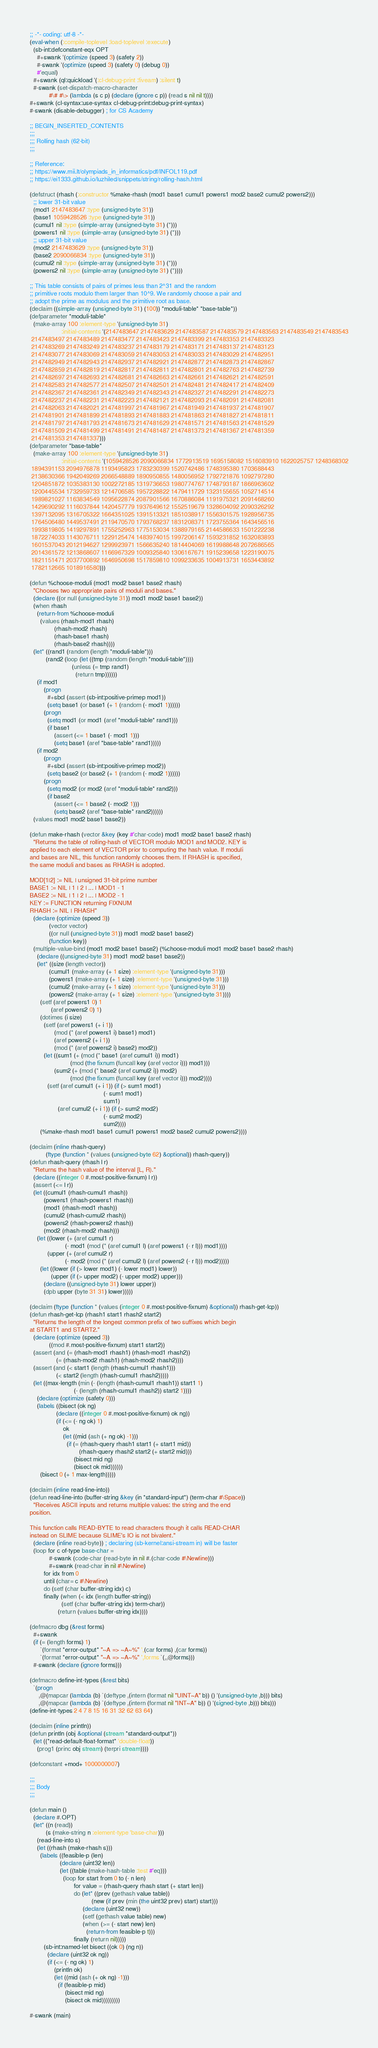Convert code to text. <code><loc_0><loc_0><loc_500><loc_500><_Lisp_>;; -*- coding: utf-8 -*-
(eval-when (:compile-toplevel :load-toplevel :execute)
  (sb-int:defconstant-eqx OPT
    #+swank '(optimize (speed 3) (safety 2))
    #-swank '(optimize (speed 3) (safety 0) (debug 0))
    #'equal)
  #+swank (ql:quickload '(:cl-debug-print :fiveam) :silent t)
  #-swank (set-dispatch-macro-character
           #\# #\> (lambda (s c p) (declare (ignore c p)) (read s nil nil t))))
#+swank (cl-syntax:use-syntax cl-debug-print:debug-print-syntax)
#-swank (disable-debugger) ; for CS Academy

;; BEGIN_INSERTED_CONTENTS
;;;
;;; Rolling hash (62-bit)
;;;

;; Reference:
;; https://www.mii.lt/olympiads_in_informatics/pdf/INFOL119.pdf
;; https://ei1333.github.io/luzhiled/snippets/string/rolling-hash.html

(defstruct (rhash (:constructor %make-rhash (mod1 base1 cumul1 powers1 mod2 base2 cumul2 powers2)))
  ;; lower 31-bit value
  (mod1 2147483647 :type (unsigned-byte 31))
  (base1 1059428526 :type (unsigned-byte 31))
  (cumul1 nil :type (simple-array (unsigned-byte 31) (*)))
  (powers1 nil :type (simple-array (unsigned-byte 31) (*)))
  ;; upper 31-bit value
  (mod2 2147483629 :type (unsigned-byte 31))
  (base2 2090066834 :type (unsigned-byte 31))
  (cumul2 nil :type (simple-array (unsigned-byte 31) (*)))
  (powers2 nil :type (simple-array (unsigned-byte 31) (*))))

;; This table consists of pairs of primes less than 2^31 and the random
;; primitive roots modulo them larger than 10^9. We randomly choose a pair and
;; adopt the prime as modulus and the primitive root as base.
(declaim ((simple-array (unsigned-byte 31) (100)) *moduli-table* *base-table*))
(defparameter *moduli-table*
  (make-array 100 :element-type '(unsigned-byte 31)
                  :initial-contents '(2147483647 2147483629 2147483587 2147483579 2147483563 2147483549 2147483543
 2147483497 2147483489 2147483477 2147483423 2147483399 2147483353 2147483323
 2147483269 2147483249 2147483237 2147483179 2147483171 2147483137 2147483123
 2147483077 2147483069 2147483059 2147483053 2147483033 2147483029 2147482951
 2147482949 2147482943 2147482937 2147482921 2147482877 2147482873 2147482867
 2147482859 2147482819 2147482817 2147482811 2147482801 2147482763 2147482739
 2147482697 2147482693 2147482681 2147482663 2147482661 2147482621 2147482591
 2147482583 2147482577 2147482507 2147482501 2147482481 2147482417 2147482409
 2147482367 2147482361 2147482349 2147482343 2147482327 2147482291 2147482273
 2147482237 2147482231 2147482223 2147482121 2147482093 2147482091 2147482081
 2147482063 2147482021 2147481997 2147481967 2147481949 2147481937 2147481907
 2147481901 2147481899 2147481893 2147481883 2147481863 2147481827 2147481811
 2147481797 2147481793 2147481673 2147481629 2147481571 2147481563 2147481529
 2147481509 2147481499 2147481491 2147481487 2147481373 2147481367 2147481359
 2147481353 2147481337)))
(defparameter *base-table*
  (make-array 100 :element-type '(unsigned-byte 31)
                  :initial-contents '(1059428526 2090066834 1772913519 1695158082 1516083910 1622025757 1248368302
 1894391153 2094976878 1193495823 1783230399 1520742486 1748395380 1703688443
 2138630366 1942049269 2066548889 1890950855 1480056952 1792721876 1092797280
 1204851872 1035383130 1002272185 1319736653 1980774767 1748793187 1866963602
 1200445534 1732959733 1214706585 1957228822 1479411729 1323155655 1052714514
 1989821027 1163834549 1095622874 2087901566 1670886084 1191975321 2091468260
 1429690292 1116037844 1420457779 1937649612 1552519679 1328604092 2090326292
 1397132095 1316705322 1664351025 1391513321 1851038917 1556301575 1928956735
 1764506480 1449537491 2119470570 1793768237 1831208371 1723755364 1643456516
 1993819805 1419297891 1755252963 1775153034 1388979165 2144586633 1501222238
 1872274033 1143076711 1229125474 1483974015 1997206147 1593231852 1632083893
 1601537043 2012194627 1299923971 1566635240 1814404069 1619988648 2072686565
 2014361572 1213868607 1166967329 1009325840 1306167671 1915239658 1223190075
 1821151471 2037700892 1646950698 1517859810 1099233635 1004913731 1653443892
 1782112665 1018916580)))

(defun %choose-moduli (mod1 mod2 base1 base2 rhash)
  "Chooses two appropriate pairs of moduli and bases."
  (declare ((or null (unsigned-byte 31)) mod1 mod2 base1 base2))
  (when rhash
    (return-from %choose-moduli
      (values (rhash-mod1 rhash)
              (rhash-mod2 rhash)
              (rhash-base1 rhash)
              (rhash-base2 rhash))))
  (let* ((rand1 (random (length *moduli-table*)))
         (rand2 (loop (let ((tmp (random (length *moduli-table*))))
                        (unless (= tmp rand1)
                          (return tmp))))))
    (if mod1
        (progn
          #+sbcl (assert (sb-int:positive-primep mod1))
          (setq base1 (or base1 (+ 1 (random (- mod1 1))))))
        (progn
          (setq mod1 (or mod1 (aref *moduli-table* rand1)))
          (if base1
              (assert (<= 1 base1 (- mod1 1)))
              (setq base1 (aref *base-table* rand1)))))
    (if mod2
        (progn
          #+sbcl (assert (sb-int:positive-primep mod2))
          (setq base2 (or base2 (+ 1 (random (- mod2 1))))))
        (progn
          (setq mod2 (or mod2 (aref *moduli-table* rand2)))
          (if base2
              (assert (<= 1 base2 (- mod2 1)))
              (setq base2 (aref *base-table* rand2))))))
  (values mod1 mod2 base1 base2))

(defun make-rhash (vector &key (key #'char-code) mod1 mod2 base1 base2 rhash)
  "Returns the table of rolling-hash of VECTOR modulo MOD1 and MOD2. KEY is
applied to each element of VECTOR prior to computing the hash value. If moduli
and bases are NIL, this function randomly chooses them. If RHASH is specified,
the same moduli and bases as RHASH is adopted.

MOD[1|2] := NIL | unsigned 31-bit prime number
BASE1 := NIL | 1 | 2 | ... | MOD1 - 1
BASE2 := NIL | 1 | 2 | ... | MOD2 - 1
KEY := FUNCTION returning FIXNUM
RHASH := NIL | RHASH"
  (declare (optimize (speed 3))
           (vector vector)
           ((or null (unsigned-byte 31)) mod1 mod2 base1 base2)
           (function key))
  (multiple-value-bind (mod1 mod2 base1 base2) (%choose-moduli mod1 mod2 base1 base2 rhash)
    (declare ((unsigned-byte 31) mod1 mod2 base1 base2))
    (let* ((size (length vector))
           (cumul1 (make-array (+ 1 size) :element-type '(unsigned-byte 31)))
           (powers1 (make-array (+ 1 size) :element-type '(unsigned-byte 31)))
           (cumul2 (make-array (+ 1 size) :element-type '(unsigned-byte 31)))
           (powers2 (make-array (+ 1 size) :element-type '(unsigned-byte 31))))
      (setf (aref powers1 0) 1
            (aref powers2 0) 1)
      (dotimes (i size)
        (setf (aref powers1 (+ i 1))
              (mod (* (aref powers1 i) base1) mod1)
              (aref powers2 (+ i 1))
              (mod (* (aref powers2 i) base2) mod2))
        (let ((sum1 (+ (mod (* base1 (aref cumul1 i)) mod1)
                       (mod (the fixnum (funcall key (aref vector i))) mod1)))
              (sum2 (+ (mod (* base2 (aref cumul2 i)) mod2)
                       (mod (the fixnum (funcall key (aref vector i))) mod2))))
          (setf (aref cumul1 (+ i 1)) (if (> sum1 mod1)
                                          (- sum1 mod1)
                                          sum1)
                (aref cumul2 (+ i 1)) (if (> sum2 mod2)
                                          (- sum2 mod2)
                                          sum2))))
      (%make-rhash mod1 base1 cumul1 powers1 mod2 base2 cumul2 powers2))))

(declaim (inline rhash-query)
         (ftype (function * (values (unsigned-byte 62) &optional)) rhash-query))
(defun rhash-query (rhash l r)
  "Returns the hash value of the interval [L, R)."
  (declare ((integer 0 #.most-positive-fixnum) l r))
  (assert (<= l r))
  (let ((cumul1 (rhash-cumul1 rhash))
        (powers1 (rhash-powers1 rhash))
        (mod1 (rhash-mod1 rhash))
        (cumul2 (rhash-cumul2 rhash))
        (powers2 (rhash-powers2 rhash))
        (mod2 (rhash-mod2 rhash)))
    (let ((lower (+ (aref cumul1 r)
                    (- mod1 (mod (* (aref cumul1 l) (aref powers1 (- r l))) mod1))))
          (upper (+ (aref cumul2 r)
                    (- mod2 (mod (* (aref cumul2 l) (aref powers2 (- r l))) mod2)))))
      (let ((lower (if (> lower mod1) (- lower mod1) lower))
            (upper (if (> upper mod2) (- upper mod2) upper)))
        (declare ((unsigned-byte 31) lower upper))
        (dpb upper (byte 31 31) lower)))))

(declaim (ftype (function * (values (integer 0 #.most-positive-fixnum) &optional)) rhash-get-lcp))
(defun rhash-get-lcp (rhash1 start1 rhash2 start2)
  "Returns the length of the longest common prefix of two suffixes which begin
at START1 and START2."
  (declare (optimize (speed 3))
           ((mod #.most-positive-fixnum) start1 start2))
  (assert (and (= (rhash-mod1 rhash1) (rhash-mod1 rhash2))
               (= (rhash-mod2 rhash1) (rhash-mod2 rhash2))))
  (assert (and (< start1 (length (rhash-cumul1 rhash1)))
               (< start2 (length (rhash-cumul1 rhash2)))))
  (let ((max-length (min (- (length (rhash-cumul1 rhash1)) start1 1)
                         (- (length (rhash-cumul1 rhash2)) start2 1))))
    (declare (optimize (safety 0)))
    (labels ((bisect (ok ng)
               (declare ((integer 0 #.most-positive-fixnum) ok ng))
               (if (<= (- ng ok) 1)
                   ok
                   (let ((mid (ash (+ ng ok) -1)))
                     (if (= (rhash-query rhash1 start1 (+ start1 mid))
                            (rhash-query rhash2 start2 (+ start2 mid)))
                         (bisect mid ng)
                         (bisect ok mid))))))
      (bisect 0 (+ 1 max-length)))))

(declaim (inline read-line-into))
(defun read-line-into (buffer-string &key (in *standard-input*) (term-char #\Space))
  "Receives ASCII inputs and returns multiple values: the string and the end
position.

This function calls READ-BYTE to read characters though it calls READ-CHAR
instead on SLIME because SLIME's IO is not bivalent."
  (declare (inline read-byte)) ; declaring (sb-kernel:ansi-stream in) will be faster
  (loop for c of-type base-char =
           #-swank (code-char (read-byte in nil #.(char-code #\Newline)))
           #+swank (read-char in nil #\Newline)
        for idx from 0
        until (char= c #\Newline)
        do (setf (char buffer-string idx) c)
        finally (when (< idx (length buffer-string))
                  (setf (char buffer-string idx) term-char))
                (return (values buffer-string idx))))

(defmacro dbg (&rest forms)
  #+swank
  (if (= (length forms) 1)
      `(format *error-output* "~A => ~A~%" ',(car forms) ,(car forms))
      `(format *error-output* "~A => ~A~%" ',forms `(,,@forms)))
  #-swank (declare (ignore forms)))

(defmacro define-int-types (&rest bits)
  `(progn
     ,@(mapcar (lambda (b) `(deftype ,(intern (format nil "UINT~A" b)) () '(unsigned-byte ,b))) bits)
     ,@(mapcar (lambda (b) `(deftype ,(intern (format nil "INT~A" b)) () '(signed-byte ,b))) bits)))
(define-int-types 2 4 7 8 15 16 31 32 62 63 64)

(declaim (inline println))
(defun println (obj &optional (stream *standard-output*))
  (let ((*read-default-float-format* 'double-float))
    (prog1 (princ obj stream) (terpri stream))))

(defconstant +mod+ 1000000007)

;;;
;;; Body
;;;

(defun main ()
  (declare #.OPT)
  (let* ((n (read))
         (s (make-string n :element-type 'base-char)))
    (read-line-into s)
    (let ((rhash (make-rhash s)))
      (labels ((feasible-p (len)
                 (declare (uint32 len))
                 (let ((table (make-hash-table :test #'eq)))
                   (loop for start from 0 to (- n len)
                         for value = (rhash-query rhash start (+ start len))
                         do (let* ((prev (gethash value table))
                                   (new (if prev (min (the uint32 prev) start) start)))
                              (declare (uint32 new))
                              (setf (gethash value table) new)
                              (when (>= (- start new) len)
                                (return-from feasible-p t)))
                         finally (return nil)))))
        (sb-int:named-let bisect ((ok 0) (ng n))
          (declare (uint32 ok ng))
          (if (<= (- ng ok) 1)
              (println ok)
              (let ((mid (ash (+ ok ng) -1)))
                (if (feasible-p mid)
                    (bisect mid ng)
                    (bisect ok mid)))))))))

#-swank (main)
</code> 